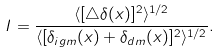Convert formula to latex. <formula><loc_0><loc_0><loc_500><loc_500>I = \frac { \langle [ \bigtriangleup \delta ( { x } ) ] ^ { 2 } \rangle ^ { 1 / 2 } } { \langle [ \delta _ { i g m } ( { x } ) + \delta _ { d m } ( { x } ) ] ^ { 2 } \rangle ^ { 1 / 2 } } .</formula> 